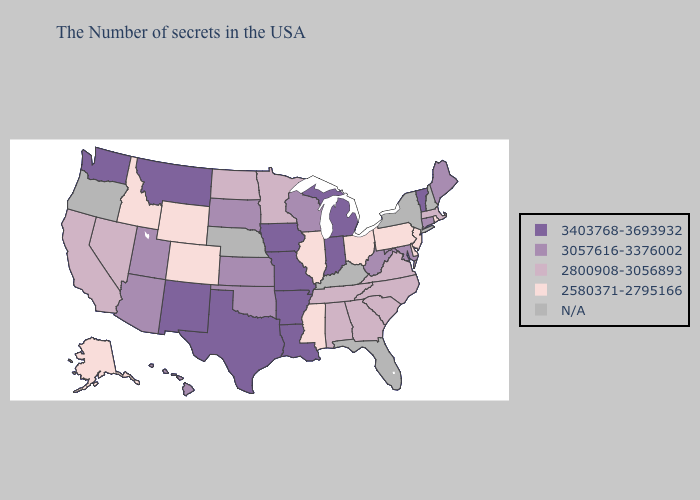Name the states that have a value in the range 3057616-3376002?
Concise answer only. Maine, Connecticut, Maryland, West Virginia, Wisconsin, Kansas, Oklahoma, South Dakota, Utah, Arizona, Hawaii. Does Missouri have the highest value in the MidWest?
Give a very brief answer. Yes. What is the value of New Mexico?
Concise answer only. 3403768-3693932. What is the value of North Carolina?
Write a very short answer. 2800908-3056893. Does Missouri have the highest value in the USA?
Write a very short answer. Yes. What is the value of Colorado?
Answer briefly. 2580371-2795166. Name the states that have a value in the range 3057616-3376002?
Give a very brief answer. Maine, Connecticut, Maryland, West Virginia, Wisconsin, Kansas, Oklahoma, South Dakota, Utah, Arizona, Hawaii. What is the value of Kentucky?
Write a very short answer. N/A. Does Pennsylvania have the lowest value in the USA?
Write a very short answer. Yes. Among the states that border Indiana , which have the highest value?
Short answer required. Michigan. Does Colorado have the highest value in the USA?
Concise answer only. No. Among the states that border Missouri , which have the lowest value?
Be succinct. Illinois. Which states have the lowest value in the South?
Keep it brief. Delaware, Mississippi. 